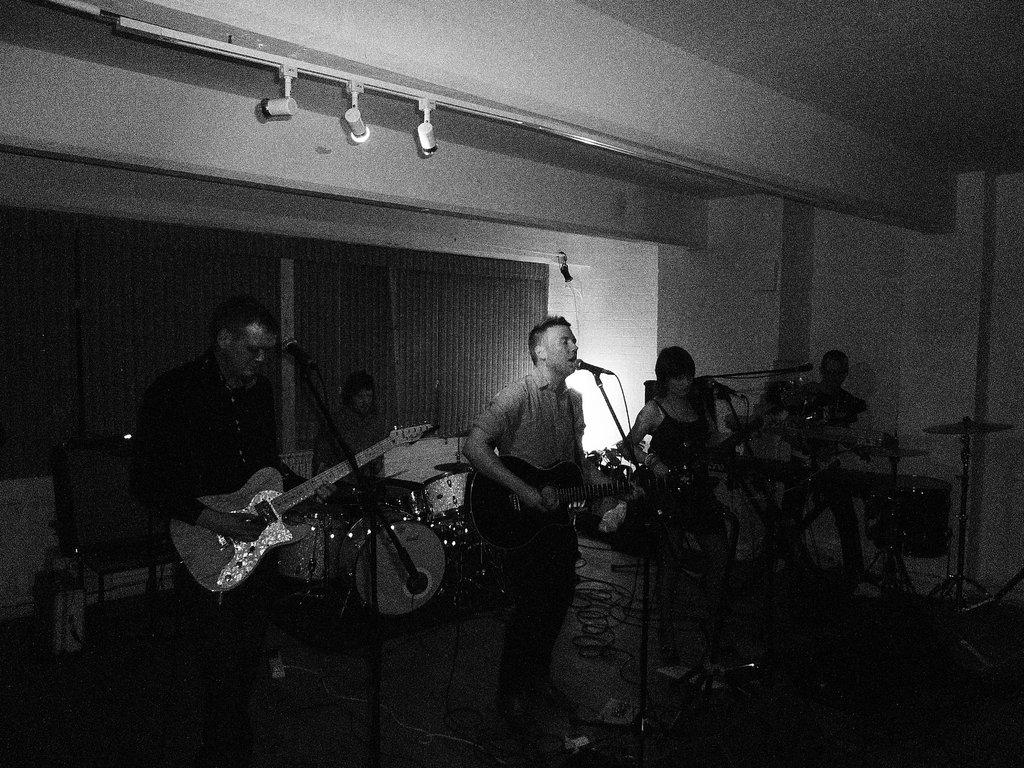How many people are in the image? There are five people in the image. What are the people doing in the image? The people are standing and playing musical instruments. What type of orange tree can be seen in the image? There is no orange tree present in the image; it features five people playing musical instruments. What is the root of the musical instruments in the image? The question is unclear, but the musical instruments themselves are not rooted in the image; they are being played by the people. 